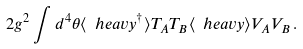Convert formula to latex. <formula><loc_0><loc_0><loc_500><loc_500>2 g ^ { 2 } \int d ^ { 4 } \theta \langle \ h e a v y ^ { \dagger } \rangle T _ { A } T _ { B } \langle \ h e a v y \rangle V _ { A } V _ { B } \, .</formula> 